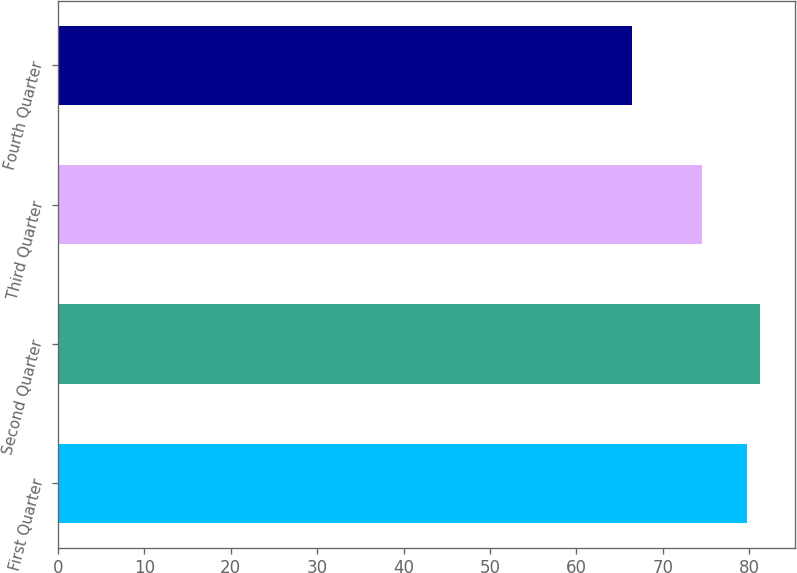<chart> <loc_0><loc_0><loc_500><loc_500><bar_chart><fcel>First Quarter<fcel>Second Quarter<fcel>Third Quarter<fcel>Fourth Quarter<nl><fcel>79.78<fcel>81.23<fcel>74.55<fcel>66.42<nl></chart> 